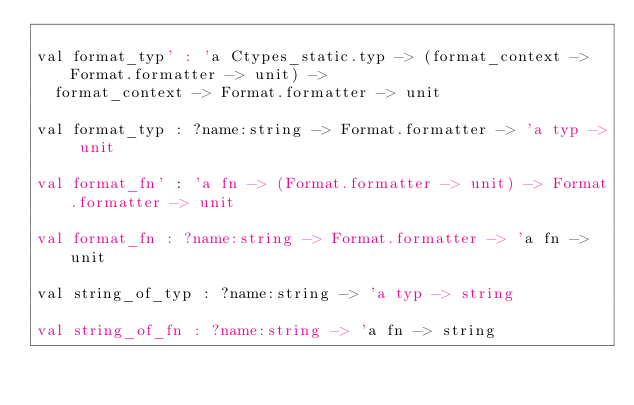<code> <loc_0><loc_0><loc_500><loc_500><_OCaml_>
val format_typ' : 'a Ctypes_static.typ -> (format_context -> Format.formatter -> unit) ->
  format_context -> Format.formatter -> unit

val format_typ : ?name:string -> Format.formatter -> 'a typ -> unit

val format_fn' : 'a fn -> (Format.formatter -> unit) -> Format.formatter -> unit

val format_fn : ?name:string -> Format.formatter -> 'a fn -> unit

val string_of_typ : ?name:string -> 'a typ -> string

val string_of_fn : ?name:string -> 'a fn -> string
</code> 